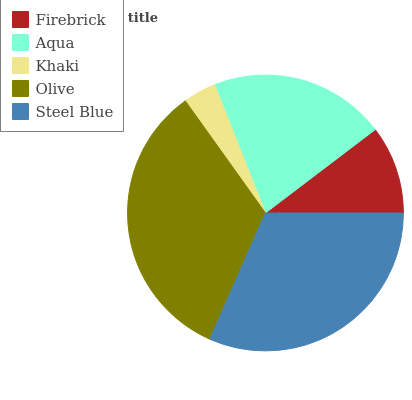Is Khaki the minimum?
Answer yes or no. Yes. Is Olive the maximum?
Answer yes or no. Yes. Is Aqua the minimum?
Answer yes or no. No. Is Aqua the maximum?
Answer yes or no. No. Is Aqua greater than Firebrick?
Answer yes or no. Yes. Is Firebrick less than Aqua?
Answer yes or no. Yes. Is Firebrick greater than Aqua?
Answer yes or no. No. Is Aqua less than Firebrick?
Answer yes or no. No. Is Aqua the high median?
Answer yes or no. Yes. Is Aqua the low median?
Answer yes or no. Yes. Is Steel Blue the high median?
Answer yes or no. No. Is Firebrick the low median?
Answer yes or no. No. 